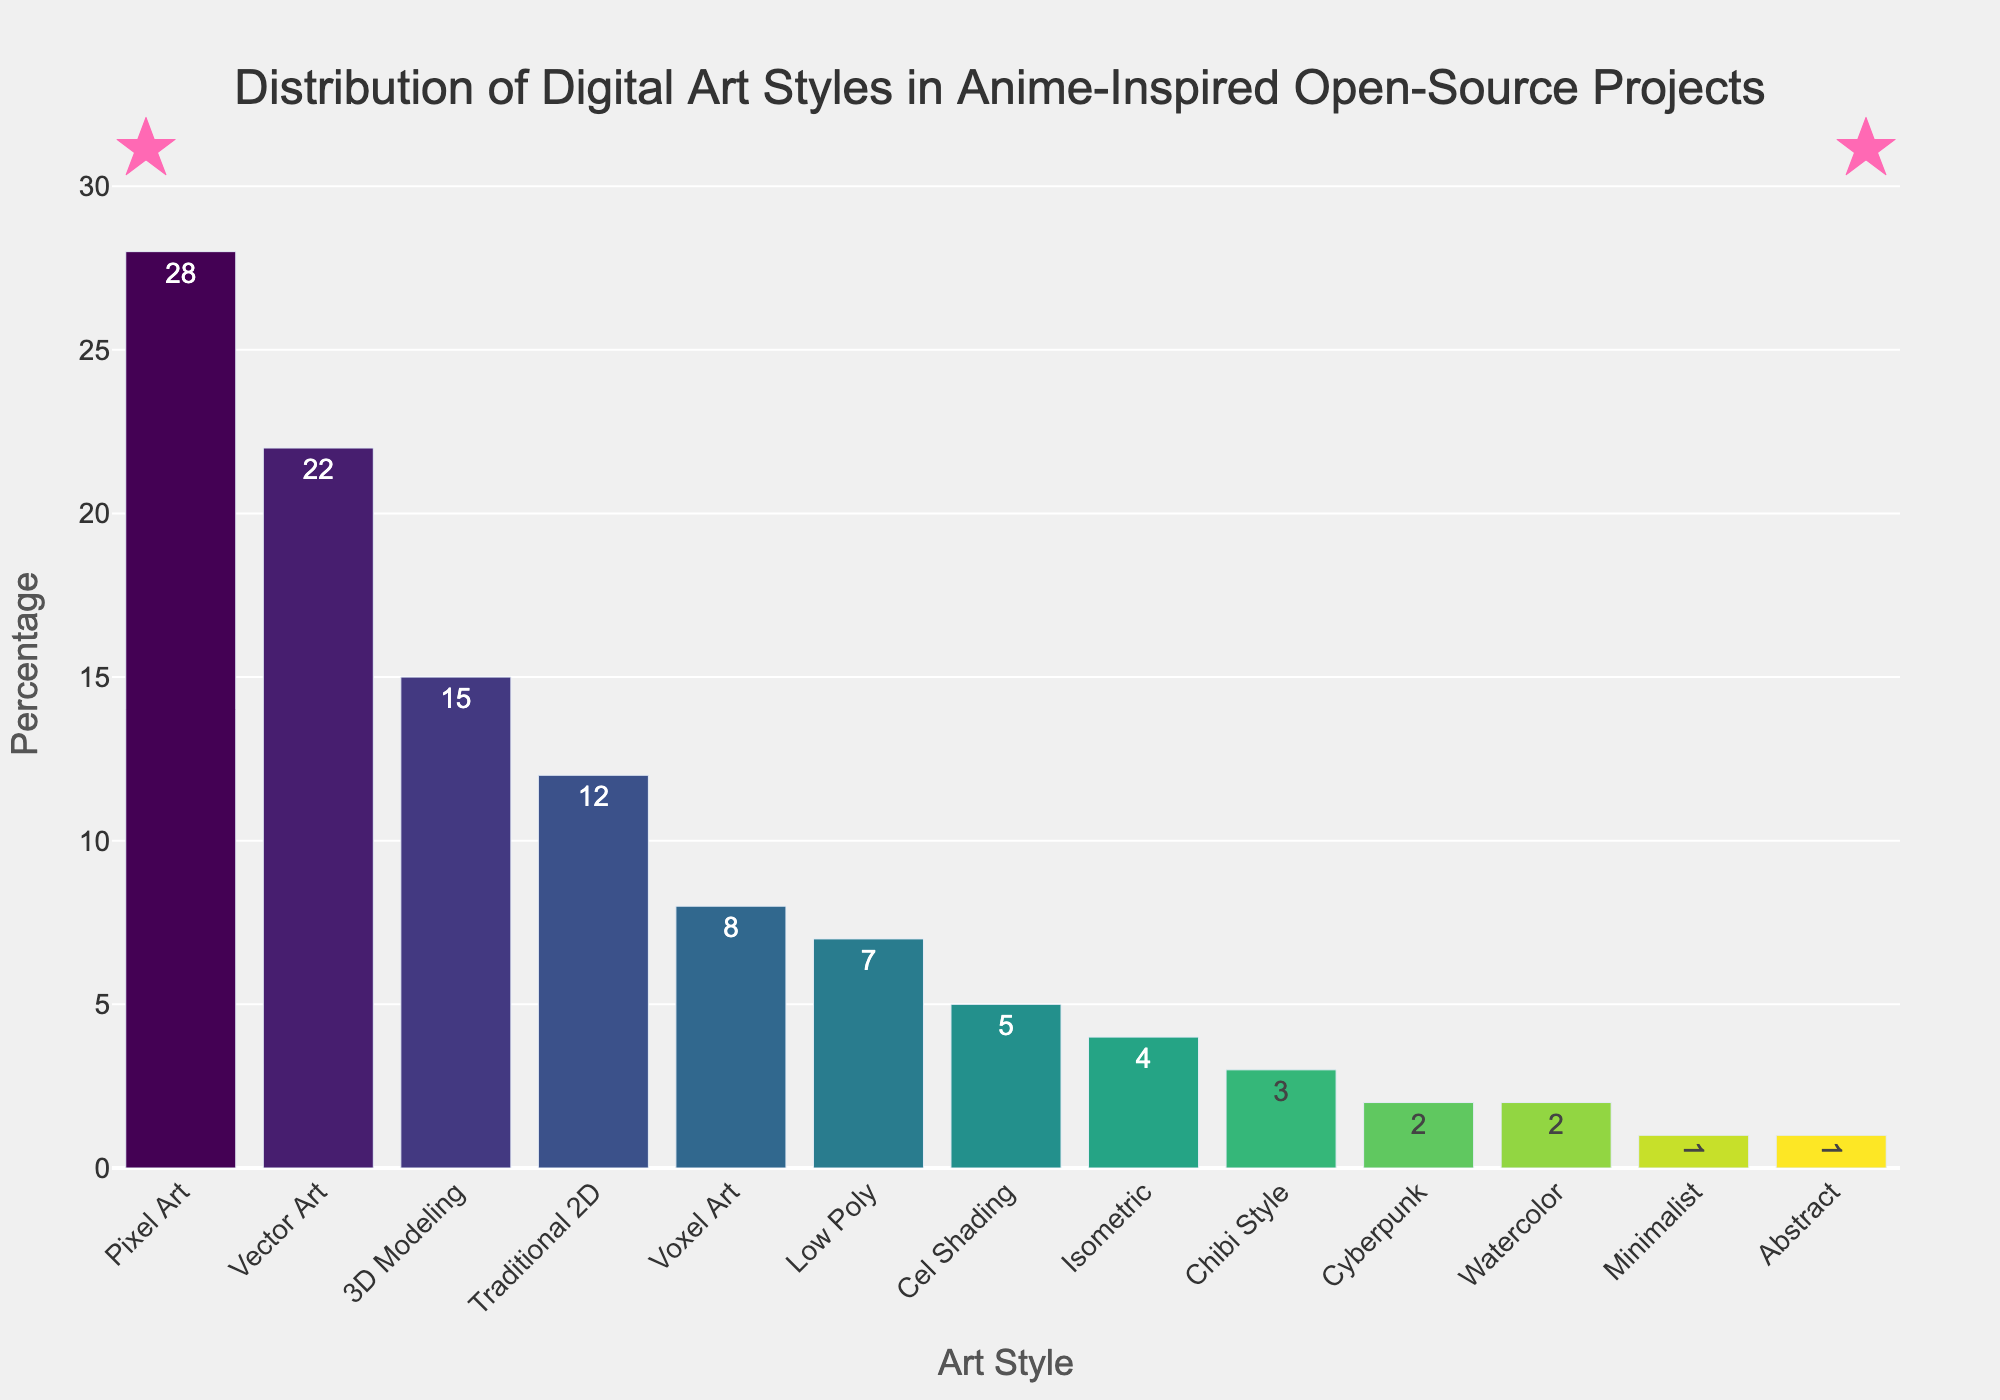Which art style has the highest percentage? The tallest bar represents the art style with the highest percentage. Based on the bar chart, Pixel Art has the highest percentage.
Answer: Pixel Art What is the combined percentage of styles that have less than 5% representation? Sum the percentages of Chibi Style (3%), Cyberpunk (2%), Watercolor (2%), Minimalist (1%), and Abstract (1%). 3 + 2 + 2 + 1 + 1 = 9
Answer: 9 Which two styles have the closest percentages, and what are their values? Compare the heights of the bars visually to find two bars that are closest in height. Traditional 2D (12%) and Voxel Art (8%) are visually close but, Voxel Art (8%) and Low Poly (7%) have the closest values.
Answer: Voxel Art (8%) and Low Poly (7%) How much larger is the percentage of Pixel Art compared to Vector Art? Subtract the percentage of Vector Art from Pixel Art. 28% - 22% = 6%
Answer: 6 How many art styles have percentages greater than 10%? Count the bars with heights corresponding to percentages greater than 10%. Pixel Art (28%), Vector Art (22%), 3D Modeling (15%), and Traditional 2D (12%) are the bars that meet this criterion.
Answer: 4 What is the average percentage of the top three art styles? Sum the percentages of the top three styles and divide by 3. (28% + 22% + 15%) / 3 = 65 / 3 = 21.67
Answer: 21.67 Is the percentage of Cel Shading greater than the average percentage of all styles? Calculate the average percentage by summing all percentages and dividing by the number of styles: (28 + 22 + 15 + 12 + 8 + 7 + 5 + 4 + 3 + 2 + 2 + 1 + 1) / 13 ≈ 8.69. Since Cel Shading is 5%, it is not greater.
Answer: No Among the least represented styles (1 or 2%), which has the lowest percentage? Identify Minimalist and Abstract (both 1%) and compare with others in the 2% group. Since Minimalist and Abstract have the same low percentage, pick one. Minimalist or Abstract
Answer: Minimalist or Abstract 